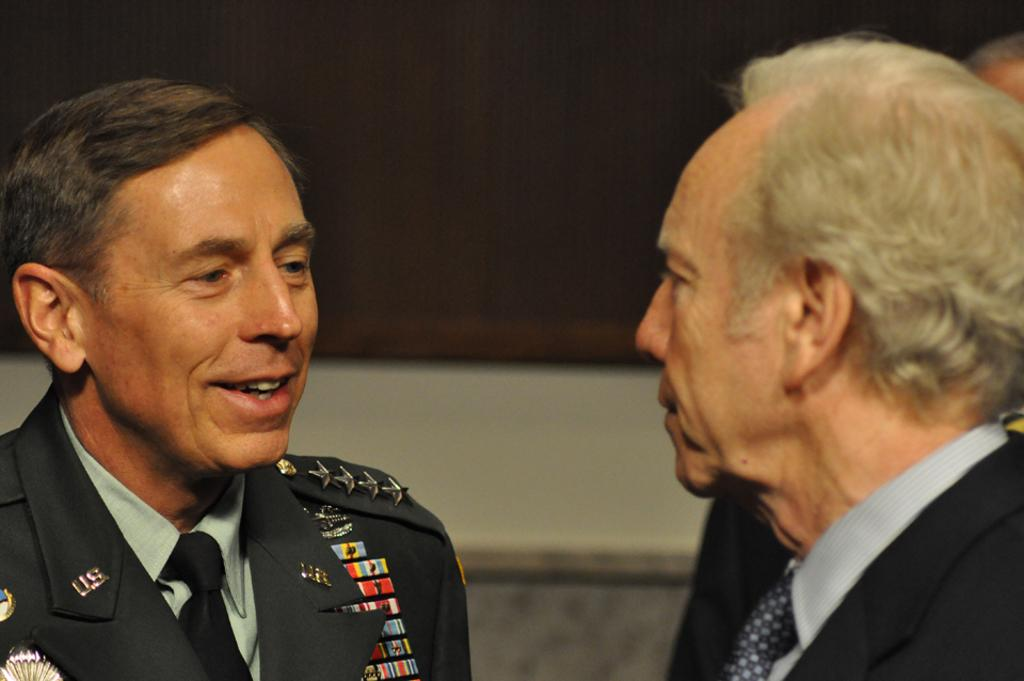How many people are present in the image? There are two people in the image. What are the two people doing in the image? The two people are facing each other. What is the person on the left side doing? The person on the left side is talking to the person on the right side. What type of space is visible in the background of the image? There is no space or background visible in the image, as it only features two people facing each other. What is the person on the right side holding in the image? There is no person on the right side holding a banana or any other object in the image. 